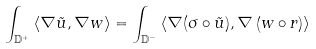<formula> <loc_0><loc_0><loc_500><loc_500>\int _ { \mathbb { D } ^ { + } } \left \langle \nabla \tilde { u } , \nabla w \right \rangle = \int _ { \mathbb { D } ^ { - } } \left \langle \nabla ( \sigma \circ \tilde { u } ) , \nabla \left ( w \circ r \right ) \right \rangle</formula> 